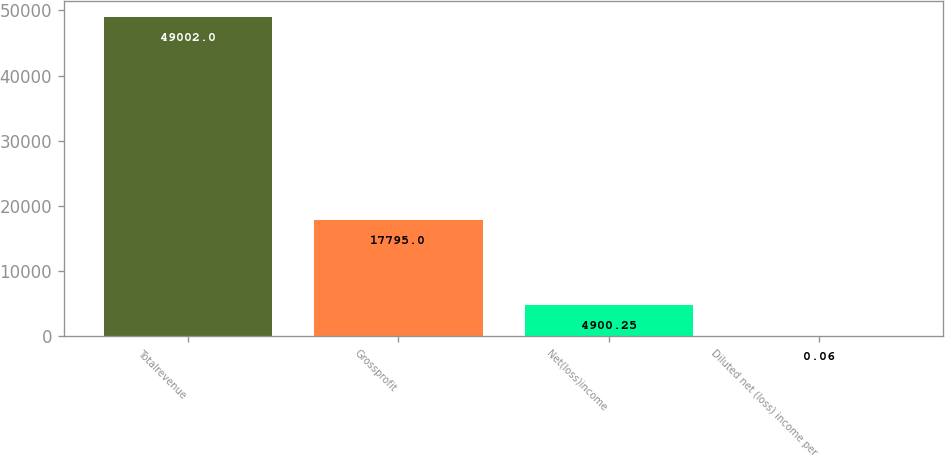Convert chart to OTSL. <chart><loc_0><loc_0><loc_500><loc_500><bar_chart><fcel>Totalrevenue<fcel>Grossprofit<fcel>Net(loss)income<fcel>Diluted net (loss) income per<nl><fcel>49002<fcel>17795<fcel>4900.25<fcel>0.06<nl></chart> 